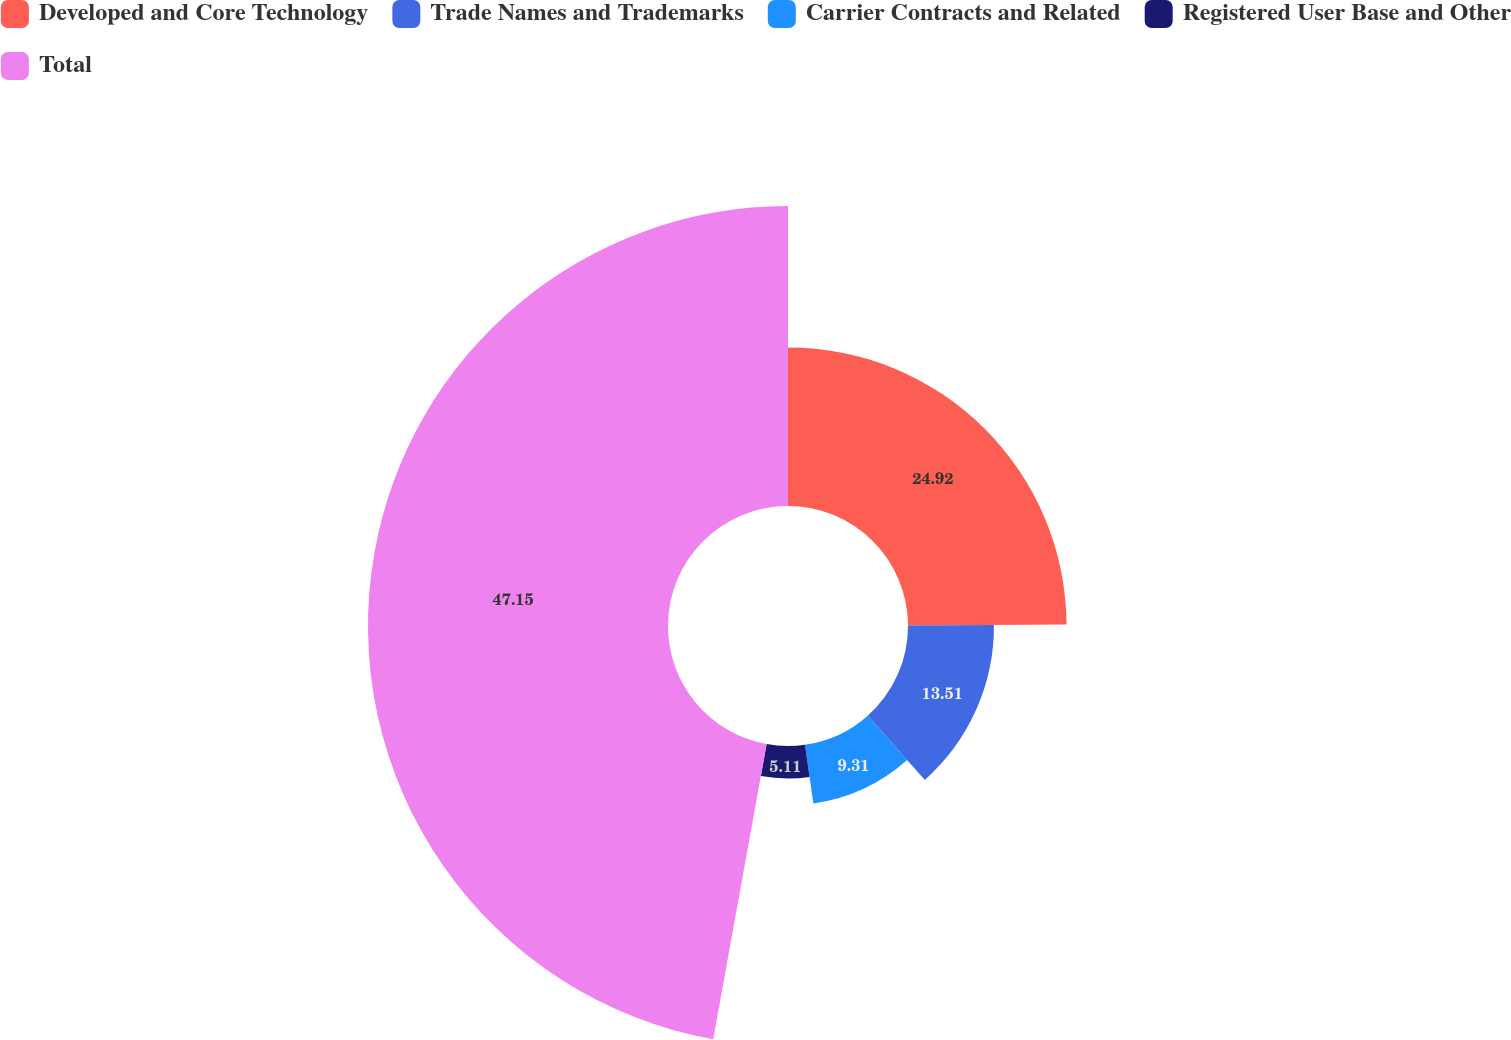<chart> <loc_0><loc_0><loc_500><loc_500><pie_chart><fcel>Developed and Core Technology<fcel>Trade Names and Trademarks<fcel>Carrier Contracts and Related<fcel>Registered User Base and Other<fcel>Total<nl><fcel>24.92%<fcel>13.51%<fcel>9.31%<fcel>5.11%<fcel>47.15%<nl></chart> 